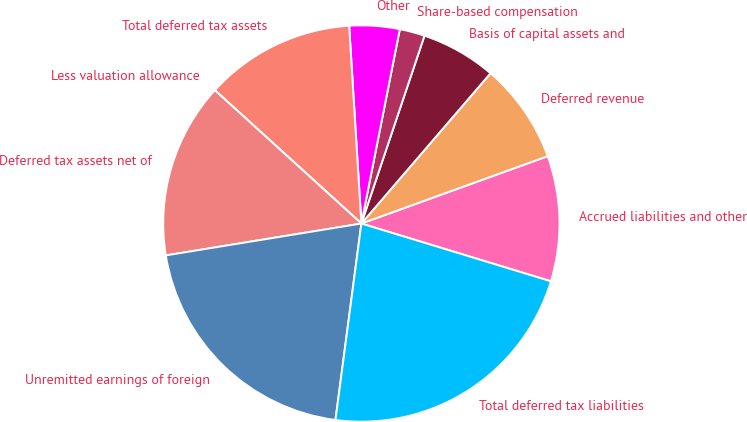Convert chart. <chart><loc_0><loc_0><loc_500><loc_500><pie_chart><fcel>Accrued liabilities and other<fcel>Deferred revenue<fcel>Basis of capital assets and<fcel>Share-based compensation<fcel>Other<fcel>Total deferred tax assets<fcel>Less valuation allowance<fcel>Deferred tax assets net of<fcel>Unremitted earnings of foreign<fcel>Total deferred tax liabilities<nl><fcel>10.23%<fcel>8.18%<fcel>6.14%<fcel>2.05%<fcel>4.09%<fcel>12.27%<fcel>0.0%<fcel>14.32%<fcel>20.34%<fcel>22.38%<nl></chart> 